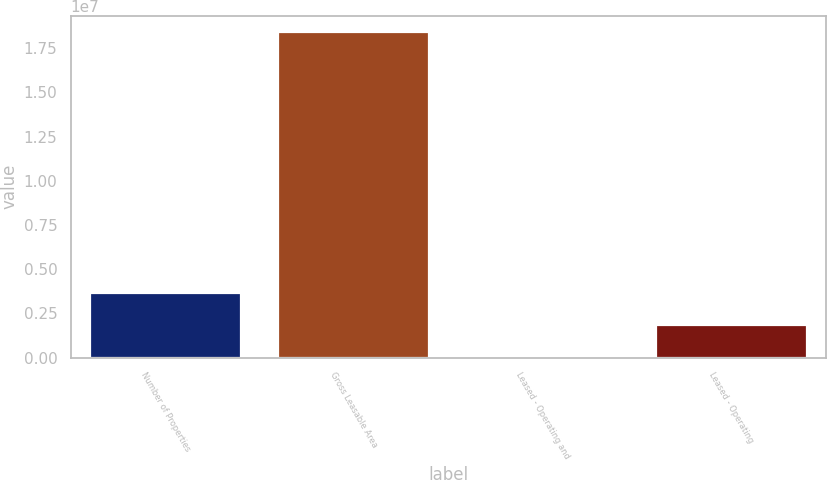<chart> <loc_0><loc_0><loc_500><loc_500><bar_chart><fcel>Number of Properties<fcel>Gross Leasable Area<fcel>Leased - Operating and<fcel>Leased - Operating<nl><fcel>3.67984e+06<fcel>1.83988e+07<fcel>94.8<fcel>1.83997e+06<nl></chart> 